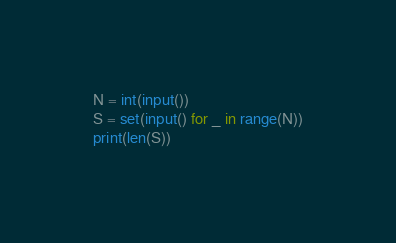Convert code to text. <code><loc_0><loc_0><loc_500><loc_500><_Python_>N = int(input())
S = set(input() for _ in range(N))
print(len(S))</code> 